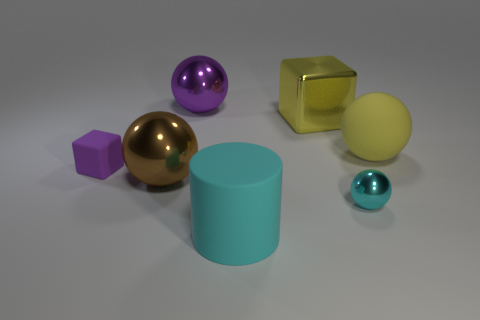Subtract all big matte balls. How many balls are left? 3 Add 1 big yellow metal things. How many objects exist? 8 Subtract all spheres. How many objects are left? 3 Subtract all purple cubes. How many cubes are left? 1 Subtract 2 spheres. How many spheres are left? 2 Subtract all small gray shiny cylinders. Subtract all large things. How many objects are left? 2 Add 3 large yellow matte objects. How many large yellow matte objects are left? 4 Add 2 large purple shiny balls. How many large purple shiny balls exist? 3 Subtract 0 red blocks. How many objects are left? 7 Subtract all brown spheres. Subtract all green cylinders. How many spheres are left? 3 